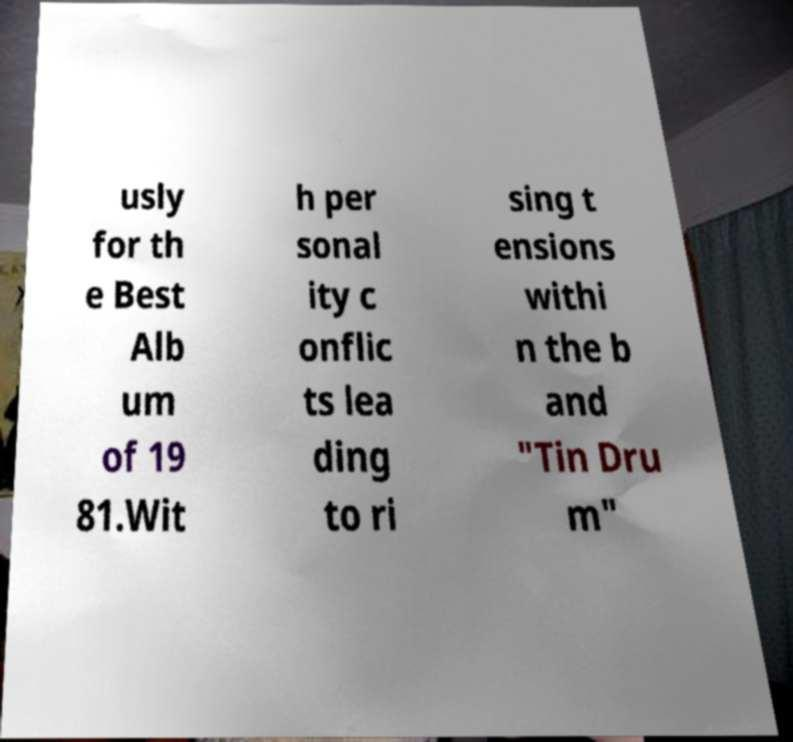What messages or text are displayed in this image? I need them in a readable, typed format. usly for th e Best Alb um of 19 81.Wit h per sonal ity c onflic ts lea ding to ri sing t ensions withi n the b and "Tin Dru m" 